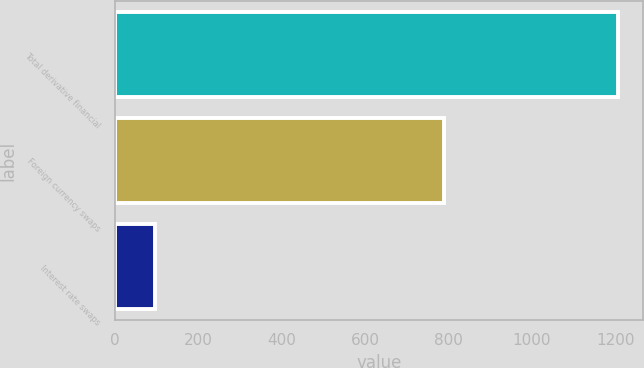<chart> <loc_0><loc_0><loc_500><loc_500><bar_chart><fcel>Total derivative financial<fcel>Foreign currency swaps<fcel>Interest rate swaps<nl><fcel>1207<fcel>789<fcel>96<nl></chart> 